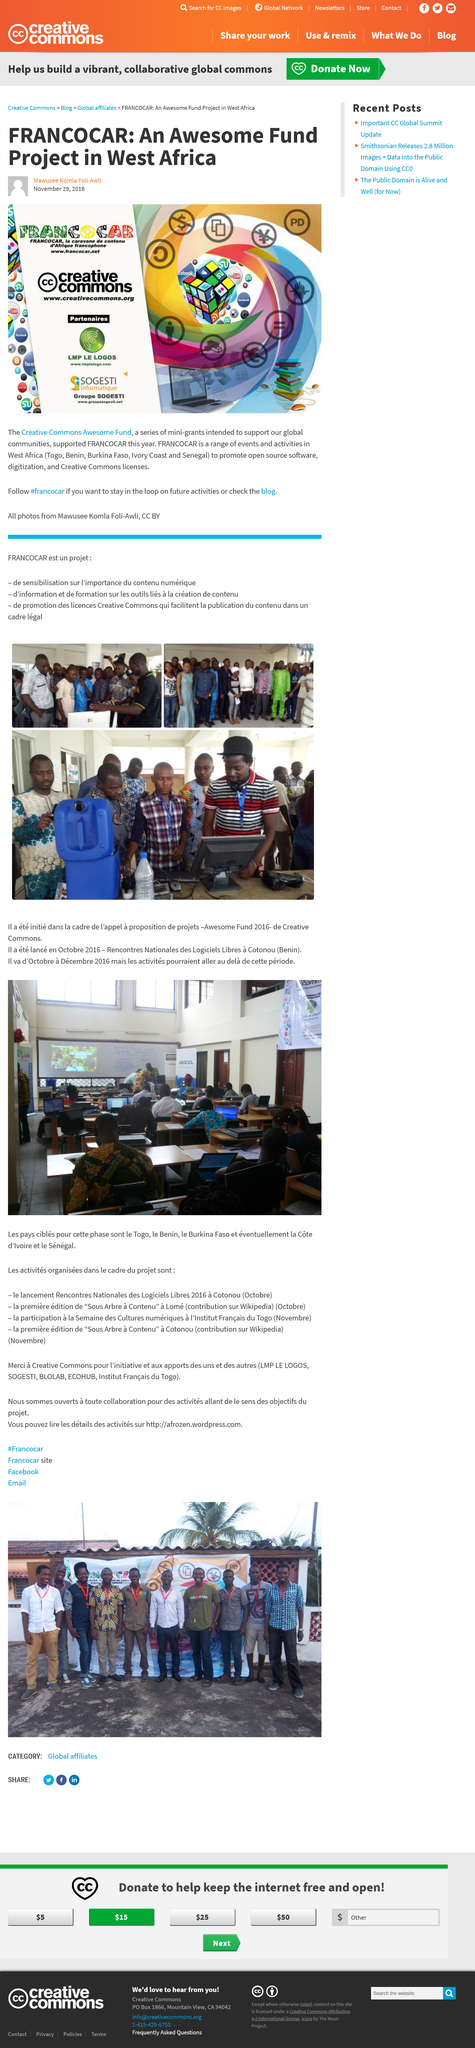Give some essential details in this illustration. Sogesti Informatique is a partner of the 2016 FRANCOCAR event. Yes, it is a partner of the event. Togo is not the name of an open source software, but rather a country in West Africa. The Creative Commons Awesome Fund is not a single event or activity taking place in Ivory Coast, but rather a series of mini-grants allocated to various activities and events in several West African countries. 